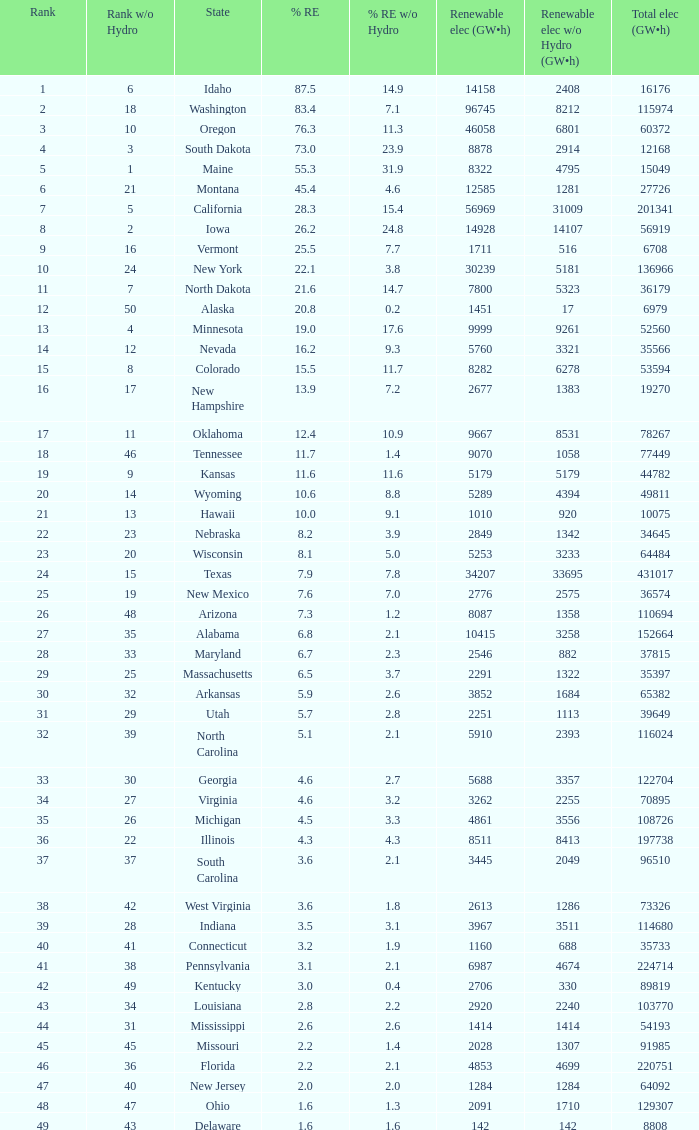What is the percentage of renewable electricity without hydrogen power in the state of South Dakota? 23.9. 